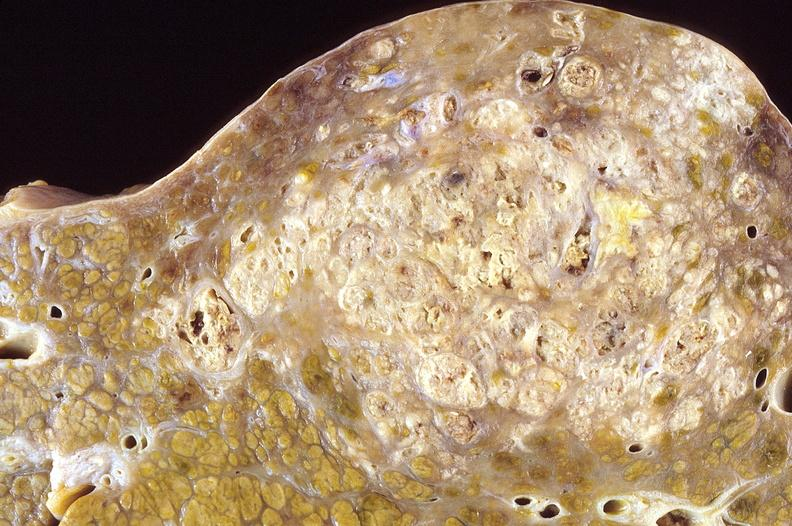s liver present?
Answer the question using a single word or phrase. Yes 